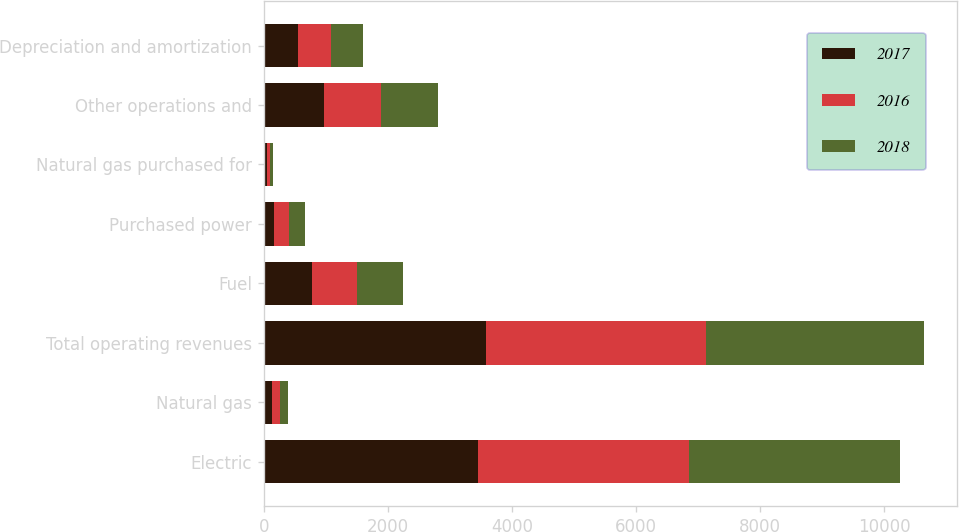Convert chart. <chart><loc_0><loc_0><loc_500><loc_500><stacked_bar_chart><ecel><fcel>Electric<fcel>Natural gas<fcel>Total operating revenues<fcel>Fuel<fcel>Purchased power<fcel>Natural gas purchased for<fcel>Other operations and<fcel>Depreciation and amortization<nl><fcel>2017<fcel>3451<fcel>138<fcel>3589<fcel>769<fcel>164<fcel>56<fcel>972<fcel>550<nl><fcel>2016<fcel>3411<fcel>126<fcel>3537<fcel>737<fcel>245<fcel>47<fcel>925<fcel>533<nl><fcel>2018<fcel>3396<fcel>128<fcel>3524<fcel>745<fcel>254<fcel>49<fcel>912<fcel>514<nl></chart> 